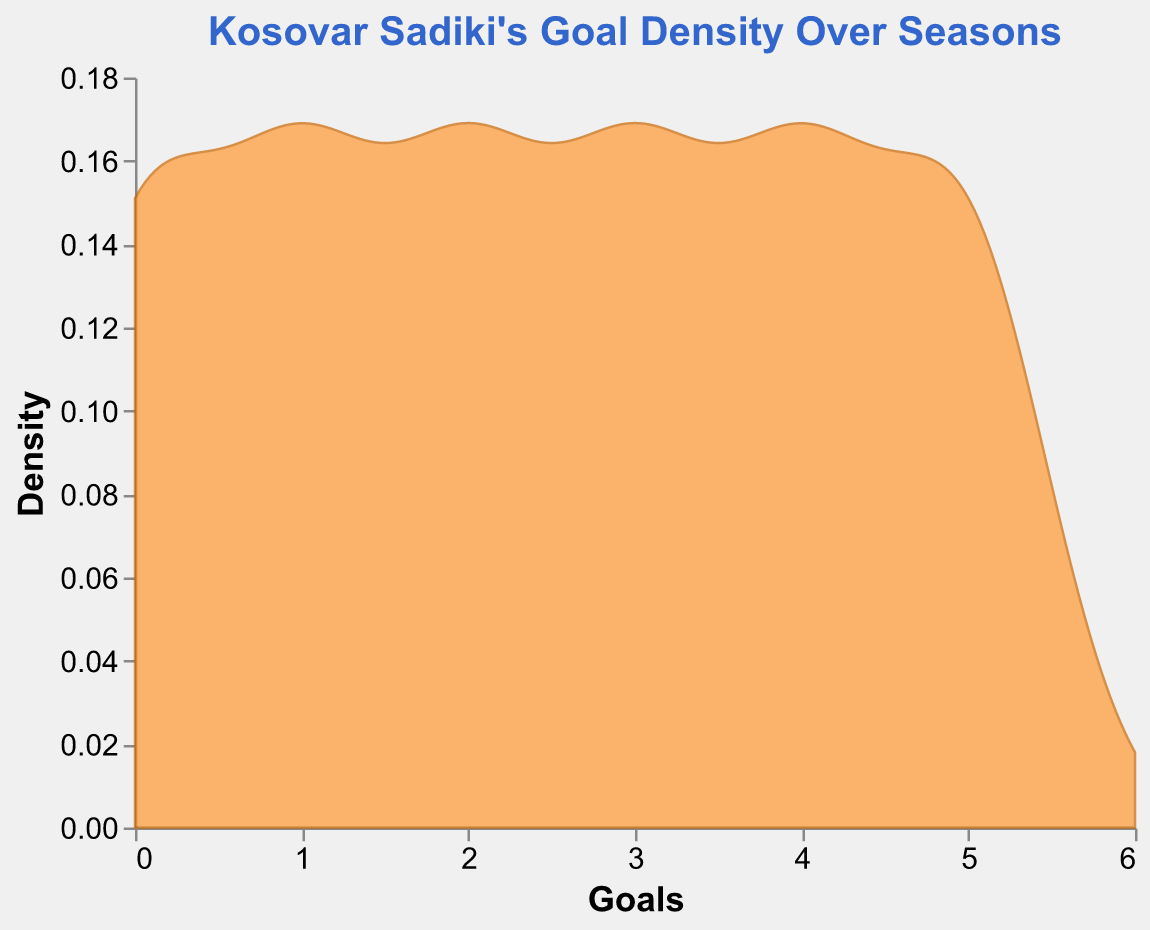what is the title of the figure? The title is prominently displayed at the top of the figure.
Answer: Kosovar Sadiki's Goal Density Over Seasons What is the maximum value on the x-axis? The x-axis represents the number of goals, and the maximum value can be observed at the far right end of the axis.
Answer: 6 What color is used for the area mark in the density plot? The area of the density plot is filled with a specific color, visible throughout the plot.
Answer: Orange What is represented by the y-axis? The y-axis indicates the variable being measured along the vertical extent of the plot.
Answer: Density What is the bandwidth used for the density estimation? Bandwidth is a parameter in density estimation and its value affects the smoothness of the density curve.
Answer: 0.5 how does the goal density change from 2018 to 2023? Observing from 2018 to 2023, the plotted density curve increases steadily, reflecting an increasing number of goals scored each season.
Answer: Density increases What season corresponds to the highest density of goals? By analyzing the plot, you can determine which season corresponds to the highest peak on the density curve.
Answer: 2023 Which season had the lowest number of goals scored? The season with the least density must correspond to the minimum point along the x-axis in terms of goals.
Answer: 2018 Is there a season with significantly different goal density compared to others? Depending on the height and shape of the density curve, some seasons may stand out as significantly different in terms of goal density.
Answer: 2023 has the highest density What is the goal density when the number of goals is zero? By looking at the y-axis value where the x-axis is zero, you can determine the density at that point.
Answer: ~0.19 